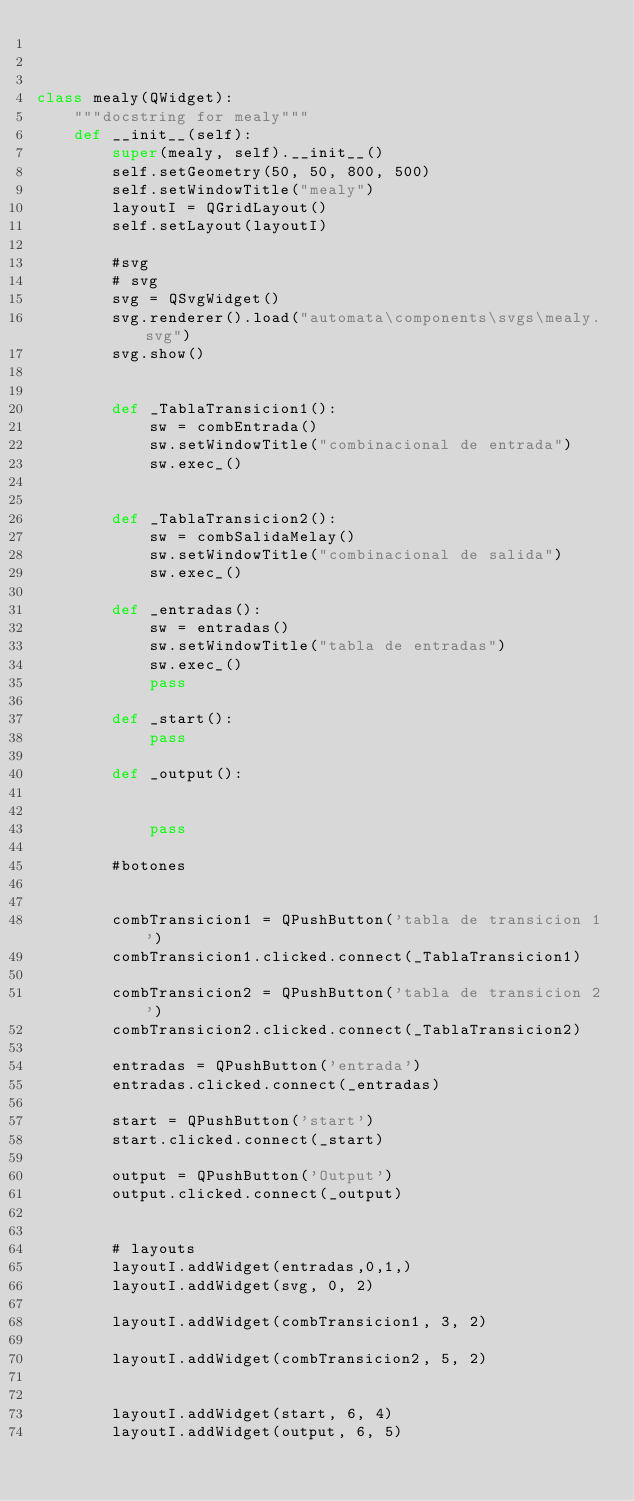Convert code to text. <code><loc_0><loc_0><loc_500><loc_500><_Python_>


class mealy(QWidget):
    """docstring for mealy"""
    def __init__(self):
        super(mealy, self).__init__()
        self.setGeometry(50, 50, 800, 500)
        self.setWindowTitle("mealy")
        layoutI = QGridLayout()
        self.setLayout(layoutI)
        
        #svg
        # svg
        svg = QSvgWidget()
        svg.renderer().load("automata\components\svgs\mealy.svg")
        svg.show()


        def _TablaTransicion1():
            sw = combEntrada()
            sw.setWindowTitle("combinacional de entrada")
            sw.exec_()


        def _TablaTransicion2():
            sw = combSalidaMelay()
            sw.setWindowTitle("combinacional de salida")
            sw.exec_()

        def _entradas():
            sw = entradas()
            sw.setWindowTitle("tabla de entradas")
            sw.exec_()
            pass

        def _start():
            pass

        def _output():
            

            pass

        #botones
 
        
        combTransicion1 = QPushButton('tabla de transicion 1')
        combTransicion1.clicked.connect(_TablaTransicion1)
        
        combTransicion2 = QPushButton('tabla de transicion 2')
        combTransicion2.clicked.connect(_TablaTransicion2)

        entradas = QPushButton('entrada')
        entradas.clicked.connect(_entradas)

        start = QPushButton('start')
        start.clicked.connect(_start)

        output = QPushButton('Output')
        output.clicked.connect(_output)


        # layouts
        layoutI.addWidget(entradas,0,1,)
        layoutI.addWidget(svg, 0, 2)

        layoutI.addWidget(combTransicion1, 3, 2)

        layoutI.addWidget(combTransicion2, 5, 2)
        

        layoutI.addWidget(start, 6, 4)
        layoutI.addWidget(output, 6, 5)
        
     
</code> 